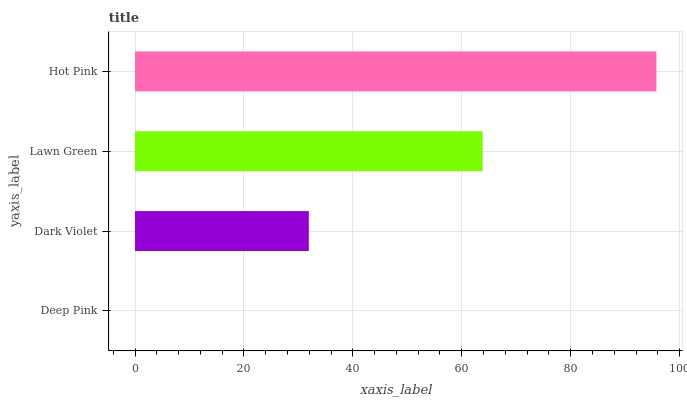Is Deep Pink the minimum?
Answer yes or no. Yes. Is Hot Pink the maximum?
Answer yes or no. Yes. Is Dark Violet the minimum?
Answer yes or no. No. Is Dark Violet the maximum?
Answer yes or no. No. Is Dark Violet greater than Deep Pink?
Answer yes or no. Yes. Is Deep Pink less than Dark Violet?
Answer yes or no. Yes. Is Deep Pink greater than Dark Violet?
Answer yes or no. No. Is Dark Violet less than Deep Pink?
Answer yes or no. No. Is Lawn Green the high median?
Answer yes or no. Yes. Is Dark Violet the low median?
Answer yes or no. Yes. Is Hot Pink the high median?
Answer yes or no. No. Is Lawn Green the low median?
Answer yes or no. No. 